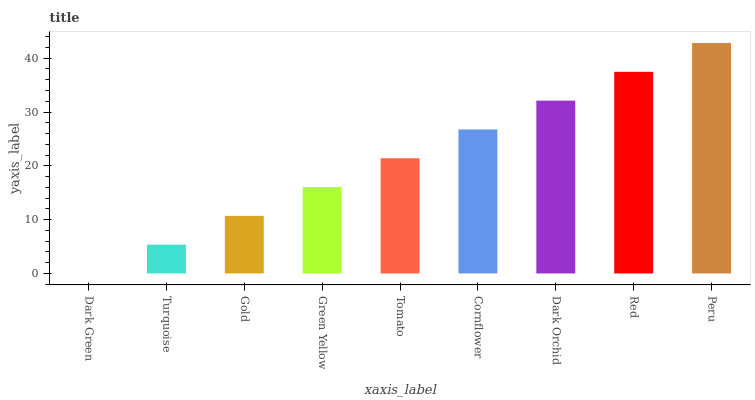Is Dark Green the minimum?
Answer yes or no. Yes. Is Peru the maximum?
Answer yes or no. Yes. Is Turquoise the minimum?
Answer yes or no. No. Is Turquoise the maximum?
Answer yes or no. No. Is Turquoise greater than Dark Green?
Answer yes or no. Yes. Is Dark Green less than Turquoise?
Answer yes or no. Yes. Is Dark Green greater than Turquoise?
Answer yes or no. No. Is Turquoise less than Dark Green?
Answer yes or no. No. Is Tomato the high median?
Answer yes or no. Yes. Is Tomato the low median?
Answer yes or no. Yes. Is Cornflower the high median?
Answer yes or no. No. Is Dark Orchid the low median?
Answer yes or no. No. 